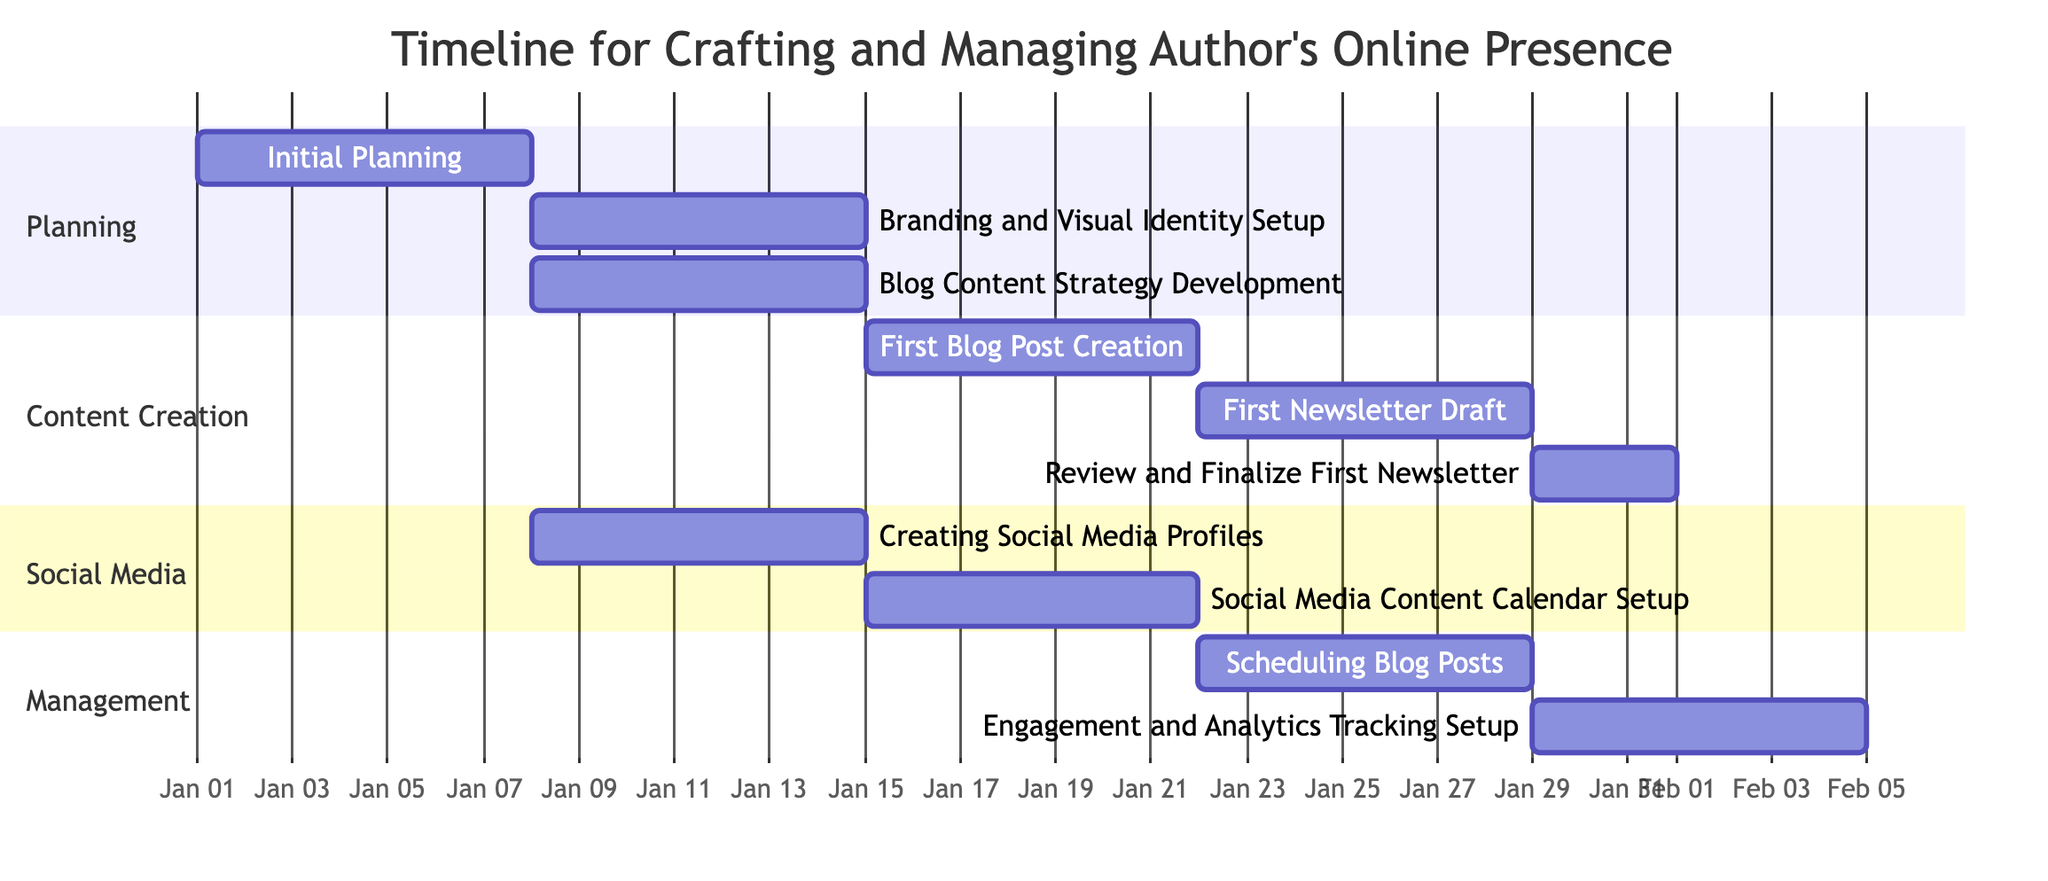what is the duration of the "Initial Planning" task? The "Initial Planning" task is scheduled from January 1, 2023, to January 7, 2023. This is a total of 7 days, as the start date and end date are inclusive.
Answer: 7 days which task comes after "Blog Content Strategy Development"? The task that comes after "Blog Content Strategy Development" is "First Blog Post Creation." According to the diagram, "First Blog Post Creation" is directly dependent on "Blog Content Strategy Development".
Answer: First Blog Post Creation how many tasks are scheduled in the "Content Creation" section? In the "Content Creation" section, there are three tasks listed: "First Blog Post Creation," "First Newsletter Draft," and "Review and Finalize First Newsletter." This can be counted directly from the diagram.
Answer: 3 tasks what is the end date of the "Engagement and Analytics Tracking Setup"? The "Engagement and Analytics Tracking Setup" task is scheduled to end on February 18, 2023. As indicated by the diagram, this task follows the completion of both "Social Media Content Calendar Setup" and "Scheduling Blog Posts."
Answer: February 18, 2023 which task has the earliest start date in the "Social Media" section? The task with the earliest start date in the "Social Media" section is "Creating Social Media Profiles," which starts on January 8, 2023. This is the only task in that section that starts first compared to others.
Answer: Creating Social Media Profiles 